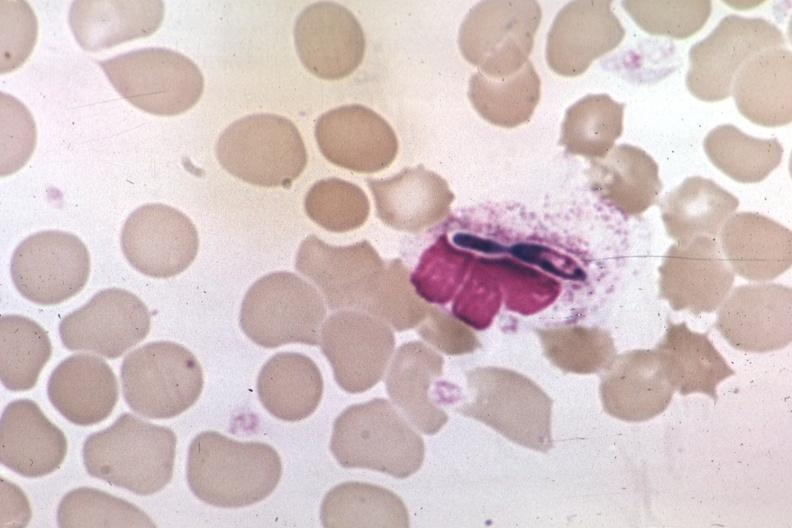s blood present?
Answer the question using a single word or phrase. Yes 